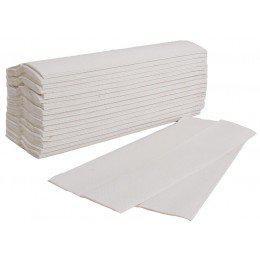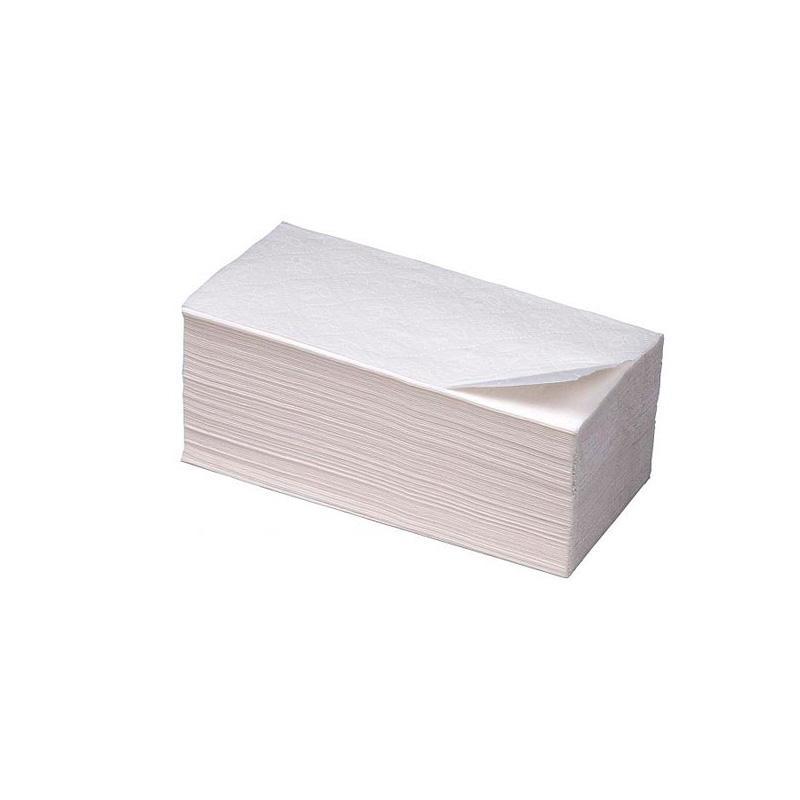The first image is the image on the left, the second image is the image on the right. Assess this claim about the two images: "An image shows one stack of solid-white folded paper towels displayed at an angle, with the top sheet opening like an accordion and draped over the front of the stack.". Correct or not? Answer yes or no. No. 